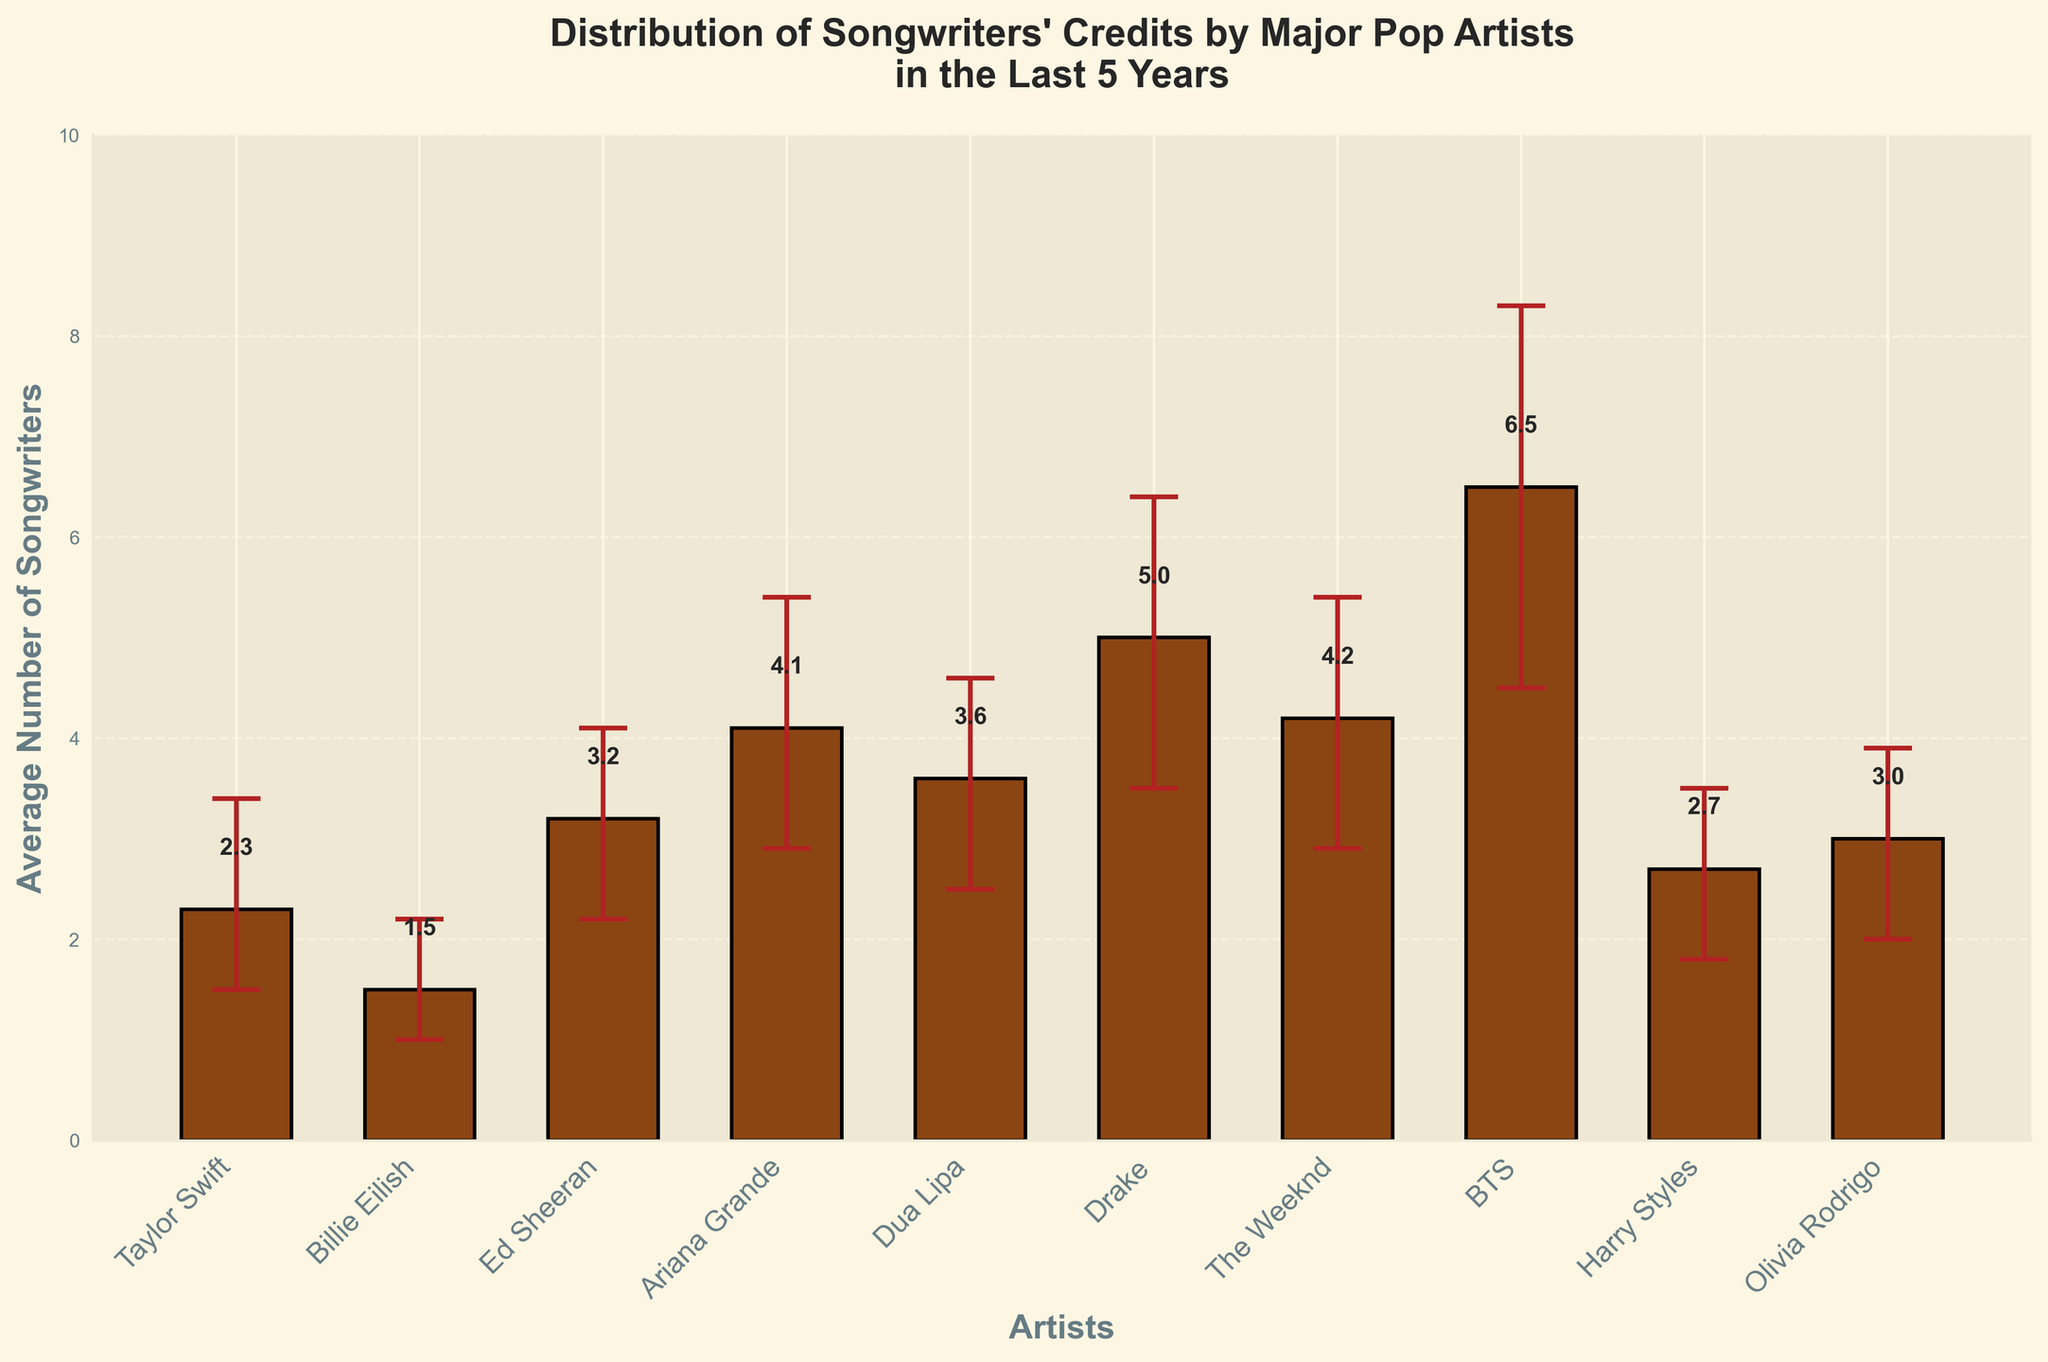How many artists are displayed in the chart? Count the number of distinct artists on the x-axis. There are 10 distinct artists: Taylor Swift, Billie Eilish, Ed Sheeran, Ariana Grande, Dua Lipa, Drake, The Weeknd, BTS, Harry Styles, and Olivia Rodrigo.
Answer: 10 Which artist has the highest average number of songwriters? Find the bar with the greatest height. BTS has the tallest bar with an average of 6.5 songwriters.
Answer: BTS What is the average number of songwriters for Ed Sheeran? Look at the label on top of Ed Sheeran's bar. It indicates an average of 3.2 songwriters.
Answer: 3.2 Which artist has the smallest variation in the number of songwriters? Compare the lengths of the error bars. Billie Eilish has the smallest error bars, with errors of 0.5 and 0.7.
Answer: Billie Eilish How much higher is the average number of songwriters for Drake compared to Billie Eilish? Subtract the average number of songwriters for Billie Eilish (1.5) from that of Drake (5.0). 5.0 - 1.5 = 3.5.
Answer: 3.5 Which two artists have an average number of songwriters close to 3.0? Look for bars near the height of 3.0 on the y-axis. Harry Styles (2.7) and Olivia Rodrigo (3.0) are close to this value.
Answer: Harry Styles, Olivia Rodrigo What is the title of the chart? Look at the top of the chart for the text description. The title is "Distribution of Songwriters' Credits by Major Pop Artists in the Last 5 Years".
Answer: Distribution of Songwriters' Credits by Major Pop Artists in the Last 5 Years How does the average number of songwriters for Taylor Swift compare to Ariana Grande? Compare the heights of the bars for Taylor Swift (2.3) and Ariana Grande (4.1). Ariana Grande has a higher average number of songwriters than Taylor Swift.
Answer: Ariana Grande has a higher average What is the range of the error bars for The Weeknd? Look at the error bars' lengths for The Weeknd, which show the variations as 1.3 and 1.2. Sum the lower (1.3) and upper (1.2) bounds to find the range. 1.3 + 1.2 = 2.5.
Answer: 2.5 Whose error bars overlap with Dua Lipa's error bars? Check the range around Dua Lipa's average of 3.6 with error bars (3.6 - 1.1 to 3.6 + 1.0). Olivia Rodrigo's average (3.0) with error bars (3.0 - 1.0 to 3.0 + 0.9) can overlap with this range.
Answer: Olivia Rodrigo 